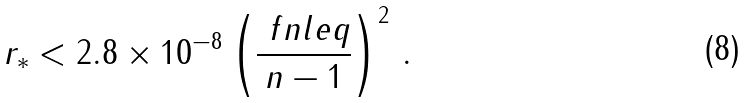<formula> <loc_0><loc_0><loc_500><loc_500>r _ { * } < 2 . 8 \times 1 0 ^ { - 8 } \left ( \frac { \ f n l e q } { n - 1 } \right ) ^ { 2 } \, .</formula> 